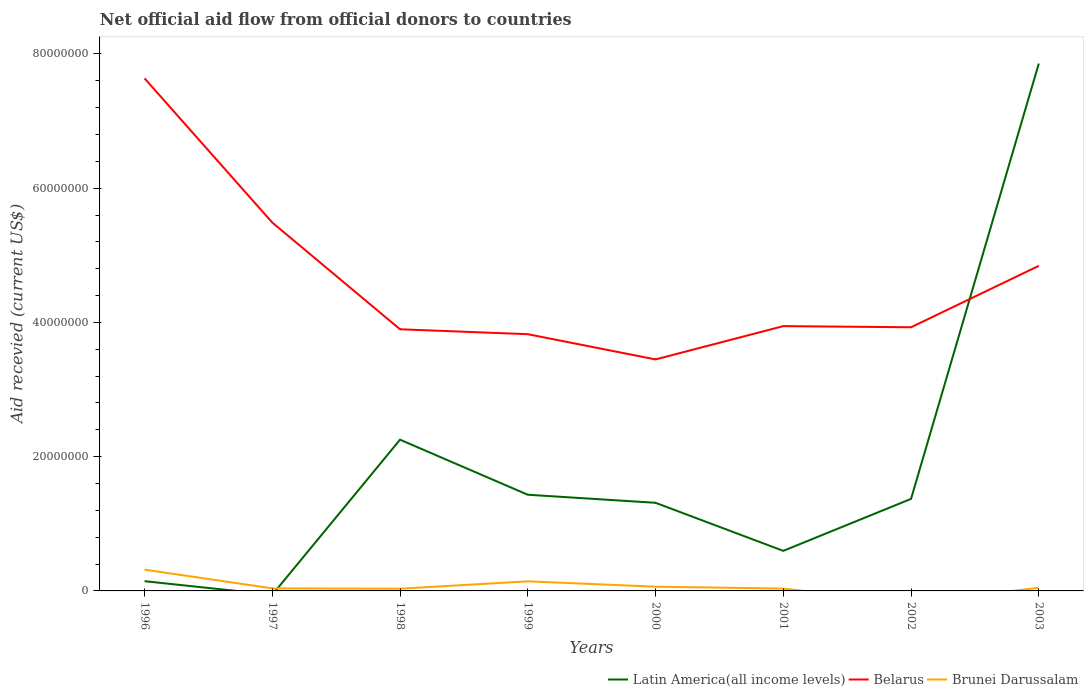Does the line corresponding to Latin America(all income levels) intersect with the line corresponding to Belarus?
Your response must be concise. Yes. Is the number of lines equal to the number of legend labels?
Offer a very short reply. No. Across all years, what is the maximum total aid received in Belarus?
Ensure brevity in your answer.  3.45e+07. What is the difference between the highest and the second highest total aid received in Belarus?
Ensure brevity in your answer.  4.19e+07. Is the total aid received in Latin America(all income levels) strictly greater than the total aid received in Belarus over the years?
Provide a short and direct response. No. What is the difference between two consecutive major ticks on the Y-axis?
Offer a terse response. 2.00e+07. Does the graph contain grids?
Keep it short and to the point. No. Where does the legend appear in the graph?
Keep it short and to the point. Bottom right. How many legend labels are there?
Ensure brevity in your answer.  3. What is the title of the graph?
Your answer should be compact. Net official aid flow from official donors to countries. Does "Europe(all income levels)" appear as one of the legend labels in the graph?
Offer a very short reply. No. What is the label or title of the X-axis?
Your answer should be very brief. Years. What is the label or title of the Y-axis?
Make the answer very short. Aid recevied (current US$). What is the Aid recevied (current US$) in Latin America(all income levels) in 1996?
Make the answer very short. 1.45e+06. What is the Aid recevied (current US$) of Belarus in 1996?
Give a very brief answer. 7.64e+07. What is the Aid recevied (current US$) of Brunei Darussalam in 1996?
Give a very brief answer. 3.17e+06. What is the Aid recevied (current US$) of Latin America(all income levels) in 1997?
Provide a succinct answer. 0. What is the Aid recevied (current US$) of Belarus in 1997?
Give a very brief answer. 5.49e+07. What is the Aid recevied (current US$) in Latin America(all income levels) in 1998?
Ensure brevity in your answer.  2.25e+07. What is the Aid recevied (current US$) in Belarus in 1998?
Ensure brevity in your answer.  3.90e+07. What is the Aid recevied (current US$) of Brunei Darussalam in 1998?
Your answer should be very brief. 3.30e+05. What is the Aid recevied (current US$) of Latin America(all income levels) in 1999?
Your response must be concise. 1.43e+07. What is the Aid recevied (current US$) of Belarus in 1999?
Make the answer very short. 3.82e+07. What is the Aid recevied (current US$) of Brunei Darussalam in 1999?
Your response must be concise. 1.43e+06. What is the Aid recevied (current US$) of Latin America(all income levels) in 2000?
Ensure brevity in your answer.  1.31e+07. What is the Aid recevied (current US$) of Belarus in 2000?
Your answer should be very brief. 3.45e+07. What is the Aid recevied (current US$) in Brunei Darussalam in 2000?
Make the answer very short. 6.30e+05. What is the Aid recevied (current US$) of Latin America(all income levels) in 2001?
Your response must be concise. 5.97e+06. What is the Aid recevied (current US$) of Belarus in 2001?
Your response must be concise. 3.94e+07. What is the Aid recevied (current US$) in Latin America(all income levels) in 2002?
Provide a succinct answer. 1.37e+07. What is the Aid recevied (current US$) in Belarus in 2002?
Make the answer very short. 3.93e+07. What is the Aid recevied (current US$) in Brunei Darussalam in 2002?
Your answer should be very brief. 0. What is the Aid recevied (current US$) of Latin America(all income levels) in 2003?
Make the answer very short. 7.86e+07. What is the Aid recevied (current US$) of Belarus in 2003?
Keep it short and to the point. 4.84e+07. What is the Aid recevied (current US$) of Brunei Darussalam in 2003?
Provide a short and direct response. 4.70e+05. Across all years, what is the maximum Aid recevied (current US$) in Latin America(all income levels)?
Ensure brevity in your answer.  7.86e+07. Across all years, what is the maximum Aid recevied (current US$) in Belarus?
Ensure brevity in your answer.  7.64e+07. Across all years, what is the maximum Aid recevied (current US$) in Brunei Darussalam?
Your answer should be compact. 3.17e+06. Across all years, what is the minimum Aid recevied (current US$) of Latin America(all income levels)?
Ensure brevity in your answer.  0. Across all years, what is the minimum Aid recevied (current US$) in Belarus?
Offer a very short reply. 3.45e+07. What is the total Aid recevied (current US$) in Latin America(all income levels) in the graph?
Ensure brevity in your answer.  1.50e+08. What is the total Aid recevied (current US$) in Belarus in the graph?
Give a very brief answer. 3.70e+08. What is the total Aid recevied (current US$) in Brunei Darussalam in the graph?
Your answer should be compact. 6.76e+06. What is the difference between the Aid recevied (current US$) in Belarus in 1996 and that in 1997?
Give a very brief answer. 2.15e+07. What is the difference between the Aid recevied (current US$) in Brunei Darussalam in 1996 and that in 1997?
Your answer should be compact. 2.79e+06. What is the difference between the Aid recevied (current US$) of Latin America(all income levels) in 1996 and that in 1998?
Keep it short and to the point. -2.11e+07. What is the difference between the Aid recevied (current US$) in Belarus in 1996 and that in 1998?
Make the answer very short. 3.74e+07. What is the difference between the Aid recevied (current US$) of Brunei Darussalam in 1996 and that in 1998?
Give a very brief answer. 2.84e+06. What is the difference between the Aid recevied (current US$) in Latin America(all income levels) in 1996 and that in 1999?
Give a very brief answer. -1.29e+07. What is the difference between the Aid recevied (current US$) in Belarus in 1996 and that in 1999?
Provide a succinct answer. 3.81e+07. What is the difference between the Aid recevied (current US$) of Brunei Darussalam in 1996 and that in 1999?
Your answer should be very brief. 1.74e+06. What is the difference between the Aid recevied (current US$) in Latin America(all income levels) in 1996 and that in 2000?
Your answer should be compact. -1.17e+07. What is the difference between the Aid recevied (current US$) of Belarus in 1996 and that in 2000?
Offer a terse response. 4.19e+07. What is the difference between the Aid recevied (current US$) in Brunei Darussalam in 1996 and that in 2000?
Ensure brevity in your answer.  2.54e+06. What is the difference between the Aid recevied (current US$) in Latin America(all income levels) in 1996 and that in 2001?
Give a very brief answer. -4.52e+06. What is the difference between the Aid recevied (current US$) in Belarus in 1996 and that in 2001?
Your answer should be compact. 3.69e+07. What is the difference between the Aid recevied (current US$) of Brunei Darussalam in 1996 and that in 2001?
Ensure brevity in your answer.  2.82e+06. What is the difference between the Aid recevied (current US$) in Latin America(all income levels) in 1996 and that in 2002?
Your response must be concise. -1.23e+07. What is the difference between the Aid recevied (current US$) of Belarus in 1996 and that in 2002?
Provide a succinct answer. 3.71e+07. What is the difference between the Aid recevied (current US$) of Latin America(all income levels) in 1996 and that in 2003?
Your response must be concise. -7.71e+07. What is the difference between the Aid recevied (current US$) of Belarus in 1996 and that in 2003?
Provide a short and direct response. 2.79e+07. What is the difference between the Aid recevied (current US$) of Brunei Darussalam in 1996 and that in 2003?
Ensure brevity in your answer.  2.70e+06. What is the difference between the Aid recevied (current US$) in Belarus in 1997 and that in 1998?
Your answer should be very brief. 1.59e+07. What is the difference between the Aid recevied (current US$) of Belarus in 1997 and that in 1999?
Provide a short and direct response. 1.66e+07. What is the difference between the Aid recevied (current US$) in Brunei Darussalam in 1997 and that in 1999?
Ensure brevity in your answer.  -1.05e+06. What is the difference between the Aid recevied (current US$) in Belarus in 1997 and that in 2000?
Keep it short and to the point. 2.04e+07. What is the difference between the Aid recevied (current US$) of Brunei Darussalam in 1997 and that in 2000?
Your answer should be very brief. -2.50e+05. What is the difference between the Aid recevied (current US$) in Belarus in 1997 and that in 2001?
Your answer should be very brief. 1.54e+07. What is the difference between the Aid recevied (current US$) of Brunei Darussalam in 1997 and that in 2001?
Give a very brief answer. 3.00e+04. What is the difference between the Aid recevied (current US$) in Belarus in 1997 and that in 2002?
Ensure brevity in your answer.  1.56e+07. What is the difference between the Aid recevied (current US$) of Belarus in 1997 and that in 2003?
Keep it short and to the point. 6.45e+06. What is the difference between the Aid recevied (current US$) of Brunei Darussalam in 1997 and that in 2003?
Make the answer very short. -9.00e+04. What is the difference between the Aid recevied (current US$) in Latin America(all income levels) in 1998 and that in 1999?
Your answer should be very brief. 8.20e+06. What is the difference between the Aid recevied (current US$) in Belarus in 1998 and that in 1999?
Provide a short and direct response. 7.30e+05. What is the difference between the Aid recevied (current US$) of Brunei Darussalam in 1998 and that in 1999?
Provide a short and direct response. -1.10e+06. What is the difference between the Aid recevied (current US$) in Latin America(all income levels) in 1998 and that in 2000?
Provide a succinct answer. 9.40e+06. What is the difference between the Aid recevied (current US$) of Belarus in 1998 and that in 2000?
Your answer should be compact. 4.49e+06. What is the difference between the Aid recevied (current US$) of Brunei Darussalam in 1998 and that in 2000?
Your response must be concise. -3.00e+05. What is the difference between the Aid recevied (current US$) in Latin America(all income levels) in 1998 and that in 2001?
Ensure brevity in your answer.  1.66e+07. What is the difference between the Aid recevied (current US$) of Belarus in 1998 and that in 2001?
Your response must be concise. -4.70e+05. What is the difference between the Aid recevied (current US$) of Latin America(all income levels) in 1998 and that in 2002?
Offer a very short reply. 8.82e+06. What is the difference between the Aid recevied (current US$) in Latin America(all income levels) in 1998 and that in 2003?
Ensure brevity in your answer.  -5.60e+07. What is the difference between the Aid recevied (current US$) of Belarus in 1998 and that in 2003?
Offer a very short reply. -9.45e+06. What is the difference between the Aid recevied (current US$) of Brunei Darussalam in 1998 and that in 2003?
Keep it short and to the point. -1.40e+05. What is the difference between the Aid recevied (current US$) of Latin America(all income levels) in 1999 and that in 2000?
Your response must be concise. 1.20e+06. What is the difference between the Aid recevied (current US$) of Belarus in 1999 and that in 2000?
Your answer should be very brief. 3.76e+06. What is the difference between the Aid recevied (current US$) in Latin America(all income levels) in 1999 and that in 2001?
Offer a terse response. 8.36e+06. What is the difference between the Aid recevied (current US$) of Belarus in 1999 and that in 2001?
Offer a terse response. -1.20e+06. What is the difference between the Aid recevied (current US$) of Brunei Darussalam in 1999 and that in 2001?
Your answer should be compact. 1.08e+06. What is the difference between the Aid recevied (current US$) in Latin America(all income levels) in 1999 and that in 2002?
Provide a short and direct response. 6.20e+05. What is the difference between the Aid recevied (current US$) of Belarus in 1999 and that in 2002?
Ensure brevity in your answer.  -1.03e+06. What is the difference between the Aid recevied (current US$) in Latin America(all income levels) in 1999 and that in 2003?
Keep it short and to the point. -6.42e+07. What is the difference between the Aid recevied (current US$) in Belarus in 1999 and that in 2003?
Offer a very short reply. -1.02e+07. What is the difference between the Aid recevied (current US$) of Brunei Darussalam in 1999 and that in 2003?
Your response must be concise. 9.60e+05. What is the difference between the Aid recevied (current US$) of Latin America(all income levels) in 2000 and that in 2001?
Give a very brief answer. 7.16e+06. What is the difference between the Aid recevied (current US$) of Belarus in 2000 and that in 2001?
Your response must be concise. -4.96e+06. What is the difference between the Aid recevied (current US$) in Brunei Darussalam in 2000 and that in 2001?
Your answer should be compact. 2.80e+05. What is the difference between the Aid recevied (current US$) in Latin America(all income levels) in 2000 and that in 2002?
Keep it short and to the point. -5.80e+05. What is the difference between the Aid recevied (current US$) of Belarus in 2000 and that in 2002?
Provide a succinct answer. -4.79e+06. What is the difference between the Aid recevied (current US$) in Latin America(all income levels) in 2000 and that in 2003?
Keep it short and to the point. -6.54e+07. What is the difference between the Aid recevied (current US$) in Belarus in 2000 and that in 2003?
Ensure brevity in your answer.  -1.39e+07. What is the difference between the Aid recevied (current US$) in Latin America(all income levels) in 2001 and that in 2002?
Provide a short and direct response. -7.74e+06. What is the difference between the Aid recevied (current US$) in Belarus in 2001 and that in 2002?
Provide a short and direct response. 1.70e+05. What is the difference between the Aid recevied (current US$) of Latin America(all income levels) in 2001 and that in 2003?
Provide a succinct answer. -7.26e+07. What is the difference between the Aid recevied (current US$) of Belarus in 2001 and that in 2003?
Ensure brevity in your answer.  -8.98e+06. What is the difference between the Aid recevied (current US$) in Brunei Darussalam in 2001 and that in 2003?
Give a very brief answer. -1.20e+05. What is the difference between the Aid recevied (current US$) of Latin America(all income levels) in 2002 and that in 2003?
Ensure brevity in your answer.  -6.49e+07. What is the difference between the Aid recevied (current US$) in Belarus in 2002 and that in 2003?
Offer a terse response. -9.15e+06. What is the difference between the Aid recevied (current US$) in Latin America(all income levels) in 1996 and the Aid recevied (current US$) in Belarus in 1997?
Your response must be concise. -5.34e+07. What is the difference between the Aid recevied (current US$) of Latin America(all income levels) in 1996 and the Aid recevied (current US$) of Brunei Darussalam in 1997?
Keep it short and to the point. 1.07e+06. What is the difference between the Aid recevied (current US$) of Belarus in 1996 and the Aid recevied (current US$) of Brunei Darussalam in 1997?
Ensure brevity in your answer.  7.60e+07. What is the difference between the Aid recevied (current US$) in Latin America(all income levels) in 1996 and the Aid recevied (current US$) in Belarus in 1998?
Give a very brief answer. -3.75e+07. What is the difference between the Aid recevied (current US$) of Latin America(all income levels) in 1996 and the Aid recevied (current US$) of Brunei Darussalam in 1998?
Ensure brevity in your answer.  1.12e+06. What is the difference between the Aid recevied (current US$) in Belarus in 1996 and the Aid recevied (current US$) in Brunei Darussalam in 1998?
Make the answer very short. 7.60e+07. What is the difference between the Aid recevied (current US$) in Latin America(all income levels) in 1996 and the Aid recevied (current US$) in Belarus in 1999?
Make the answer very short. -3.68e+07. What is the difference between the Aid recevied (current US$) in Belarus in 1996 and the Aid recevied (current US$) in Brunei Darussalam in 1999?
Ensure brevity in your answer.  7.49e+07. What is the difference between the Aid recevied (current US$) of Latin America(all income levels) in 1996 and the Aid recevied (current US$) of Belarus in 2000?
Provide a succinct answer. -3.30e+07. What is the difference between the Aid recevied (current US$) in Latin America(all income levels) in 1996 and the Aid recevied (current US$) in Brunei Darussalam in 2000?
Your response must be concise. 8.20e+05. What is the difference between the Aid recevied (current US$) in Belarus in 1996 and the Aid recevied (current US$) in Brunei Darussalam in 2000?
Offer a terse response. 7.57e+07. What is the difference between the Aid recevied (current US$) of Latin America(all income levels) in 1996 and the Aid recevied (current US$) of Belarus in 2001?
Offer a terse response. -3.80e+07. What is the difference between the Aid recevied (current US$) in Latin America(all income levels) in 1996 and the Aid recevied (current US$) in Brunei Darussalam in 2001?
Offer a terse response. 1.10e+06. What is the difference between the Aid recevied (current US$) of Belarus in 1996 and the Aid recevied (current US$) of Brunei Darussalam in 2001?
Your answer should be compact. 7.60e+07. What is the difference between the Aid recevied (current US$) of Latin America(all income levels) in 1996 and the Aid recevied (current US$) of Belarus in 2002?
Keep it short and to the point. -3.78e+07. What is the difference between the Aid recevied (current US$) of Latin America(all income levels) in 1996 and the Aid recevied (current US$) of Belarus in 2003?
Ensure brevity in your answer.  -4.70e+07. What is the difference between the Aid recevied (current US$) of Latin America(all income levels) in 1996 and the Aid recevied (current US$) of Brunei Darussalam in 2003?
Your response must be concise. 9.80e+05. What is the difference between the Aid recevied (current US$) in Belarus in 1996 and the Aid recevied (current US$) in Brunei Darussalam in 2003?
Provide a succinct answer. 7.59e+07. What is the difference between the Aid recevied (current US$) in Belarus in 1997 and the Aid recevied (current US$) in Brunei Darussalam in 1998?
Offer a terse response. 5.46e+07. What is the difference between the Aid recevied (current US$) in Belarus in 1997 and the Aid recevied (current US$) in Brunei Darussalam in 1999?
Offer a very short reply. 5.34e+07. What is the difference between the Aid recevied (current US$) of Belarus in 1997 and the Aid recevied (current US$) of Brunei Darussalam in 2000?
Your answer should be very brief. 5.42e+07. What is the difference between the Aid recevied (current US$) of Belarus in 1997 and the Aid recevied (current US$) of Brunei Darussalam in 2001?
Provide a succinct answer. 5.45e+07. What is the difference between the Aid recevied (current US$) in Belarus in 1997 and the Aid recevied (current US$) in Brunei Darussalam in 2003?
Your answer should be compact. 5.44e+07. What is the difference between the Aid recevied (current US$) of Latin America(all income levels) in 1998 and the Aid recevied (current US$) of Belarus in 1999?
Provide a short and direct response. -1.57e+07. What is the difference between the Aid recevied (current US$) of Latin America(all income levels) in 1998 and the Aid recevied (current US$) of Brunei Darussalam in 1999?
Keep it short and to the point. 2.11e+07. What is the difference between the Aid recevied (current US$) in Belarus in 1998 and the Aid recevied (current US$) in Brunei Darussalam in 1999?
Make the answer very short. 3.76e+07. What is the difference between the Aid recevied (current US$) in Latin America(all income levels) in 1998 and the Aid recevied (current US$) in Belarus in 2000?
Keep it short and to the point. -1.20e+07. What is the difference between the Aid recevied (current US$) of Latin America(all income levels) in 1998 and the Aid recevied (current US$) of Brunei Darussalam in 2000?
Make the answer very short. 2.19e+07. What is the difference between the Aid recevied (current US$) in Belarus in 1998 and the Aid recevied (current US$) in Brunei Darussalam in 2000?
Provide a succinct answer. 3.84e+07. What is the difference between the Aid recevied (current US$) of Latin America(all income levels) in 1998 and the Aid recevied (current US$) of Belarus in 2001?
Make the answer very short. -1.69e+07. What is the difference between the Aid recevied (current US$) of Latin America(all income levels) in 1998 and the Aid recevied (current US$) of Brunei Darussalam in 2001?
Make the answer very short. 2.22e+07. What is the difference between the Aid recevied (current US$) of Belarus in 1998 and the Aid recevied (current US$) of Brunei Darussalam in 2001?
Your answer should be very brief. 3.86e+07. What is the difference between the Aid recevied (current US$) of Latin America(all income levels) in 1998 and the Aid recevied (current US$) of Belarus in 2002?
Your answer should be compact. -1.68e+07. What is the difference between the Aid recevied (current US$) in Latin America(all income levels) in 1998 and the Aid recevied (current US$) in Belarus in 2003?
Make the answer very short. -2.59e+07. What is the difference between the Aid recevied (current US$) in Latin America(all income levels) in 1998 and the Aid recevied (current US$) in Brunei Darussalam in 2003?
Your answer should be compact. 2.21e+07. What is the difference between the Aid recevied (current US$) of Belarus in 1998 and the Aid recevied (current US$) of Brunei Darussalam in 2003?
Provide a succinct answer. 3.85e+07. What is the difference between the Aid recevied (current US$) in Latin America(all income levels) in 1999 and the Aid recevied (current US$) in Belarus in 2000?
Offer a very short reply. -2.02e+07. What is the difference between the Aid recevied (current US$) in Latin America(all income levels) in 1999 and the Aid recevied (current US$) in Brunei Darussalam in 2000?
Provide a succinct answer. 1.37e+07. What is the difference between the Aid recevied (current US$) of Belarus in 1999 and the Aid recevied (current US$) of Brunei Darussalam in 2000?
Make the answer very short. 3.76e+07. What is the difference between the Aid recevied (current US$) in Latin America(all income levels) in 1999 and the Aid recevied (current US$) in Belarus in 2001?
Your answer should be compact. -2.51e+07. What is the difference between the Aid recevied (current US$) in Latin America(all income levels) in 1999 and the Aid recevied (current US$) in Brunei Darussalam in 2001?
Make the answer very short. 1.40e+07. What is the difference between the Aid recevied (current US$) of Belarus in 1999 and the Aid recevied (current US$) of Brunei Darussalam in 2001?
Provide a succinct answer. 3.79e+07. What is the difference between the Aid recevied (current US$) in Latin America(all income levels) in 1999 and the Aid recevied (current US$) in Belarus in 2002?
Give a very brief answer. -2.50e+07. What is the difference between the Aid recevied (current US$) in Latin America(all income levels) in 1999 and the Aid recevied (current US$) in Belarus in 2003?
Provide a short and direct response. -3.41e+07. What is the difference between the Aid recevied (current US$) of Latin America(all income levels) in 1999 and the Aid recevied (current US$) of Brunei Darussalam in 2003?
Your response must be concise. 1.39e+07. What is the difference between the Aid recevied (current US$) in Belarus in 1999 and the Aid recevied (current US$) in Brunei Darussalam in 2003?
Ensure brevity in your answer.  3.78e+07. What is the difference between the Aid recevied (current US$) of Latin America(all income levels) in 2000 and the Aid recevied (current US$) of Belarus in 2001?
Your answer should be very brief. -2.63e+07. What is the difference between the Aid recevied (current US$) in Latin America(all income levels) in 2000 and the Aid recevied (current US$) in Brunei Darussalam in 2001?
Give a very brief answer. 1.28e+07. What is the difference between the Aid recevied (current US$) of Belarus in 2000 and the Aid recevied (current US$) of Brunei Darussalam in 2001?
Offer a very short reply. 3.41e+07. What is the difference between the Aid recevied (current US$) in Latin America(all income levels) in 2000 and the Aid recevied (current US$) in Belarus in 2002?
Give a very brief answer. -2.62e+07. What is the difference between the Aid recevied (current US$) of Latin America(all income levels) in 2000 and the Aid recevied (current US$) of Belarus in 2003?
Give a very brief answer. -3.53e+07. What is the difference between the Aid recevied (current US$) of Latin America(all income levels) in 2000 and the Aid recevied (current US$) of Brunei Darussalam in 2003?
Make the answer very short. 1.27e+07. What is the difference between the Aid recevied (current US$) in Belarus in 2000 and the Aid recevied (current US$) in Brunei Darussalam in 2003?
Give a very brief answer. 3.40e+07. What is the difference between the Aid recevied (current US$) of Latin America(all income levels) in 2001 and the Aid recevied (current US$) of Belarus in 2002?
Ensure brevity in your answer.  -3.33e+07. What is the difference between the Aid recevied (current US$) in Latin America(all income levels) in 2001 and the Aid recevied (current US$) in Belarus in 2003?
Provide a short and direct response. -4.25e+07. What is the difference between the Aid recevied (current US$) in Latin America(all income levels) in 2001 and the Aid recevied (current US$) in Brunei Darussalam in 2003?
Your response must be concise. 5.50e+06. What is the difference between the Aid recevied (current US$) of Belarus in 2001 and the Aid recevied (current US$) of Brunei Darussalam in 2003?
Your answer should be compact. 3.90e+07. What is the difference between the Aid recevied (current US$) of Latin America(all income levels) in 2002 and the Aid recevied (current US$) of Belarus in 2003?
Ensure brevity in your answer.  -3.47e+07. What is the difference between the Aid recevied (current US$) of Latin America(all income levels) in 2002 and the Aid recevied (current US$) of Brunei Darussalam in 2003?
Your response must be concise. 1.32e+07. What is the difference between the Aid recevied (current US$) in Belarus in 2002 and the Aid recevied (current US$) in Brunei Darussalam in 2003?
Offer a terse response. 3.88e+07. What is the average Aid recevied (current US$) of Latin America(all income levels) per year?
Your answer should be very brief. 1.87e+07. What is the average Aid recevied (current US$) in Belarus per year?
Your answer should be compact. 4.63e+07. What is the average Aid recevied (current US$) of Brunei Darussalam per year?
Give a very brief answer. 8.45e+05. In the year 1996, what is the difference between the Aid recevied (current US$) of Latin America(all income levels) and Aid recevied (current US$) of Belarus?
Keep it short and to the point. -7.49e+07. In the year 1996, what is the difference between the Aid recevied (current US$) of Latin America(all income levels) and Aid recevied (current US$) of Brunei Darussalam?
Your response must be concise. -1.72e+06. In the year 1996, what is the difference between the Aid recevied (current US$) in Belarus and Aid recevied (current US$) in Brunei Darussalam?
Offer a terse response. 7.32e+07. In the year 1997, what is the difference between the Aid recevied (current US$) of Belarus and Aid recevied (current US$) of Brunei Darussalam?
Your answer should be compact. 5.45e+07. In the year 1998, what is the difference between the Aid recevied (current US$) in Latin America(all income levels) and Aid recevied (current US$) in Belarus?
Provide a short and direct response. -1.64e+07. In the year 1998, what is the difference between the Aid recevied (current US$) of Latin America(all income levels) and Aid recevied (current US$) of Brunei Darussalam?
Offer a very short reply. 2.22e+07. In the year 1998, what is the difference between the Aid recevied (current US$) in Belarus and Aid recevied (current US$) in Brunei Darussalam?
Your response must be concise. 3.86e+07. In the year 1999, what is the difference between the Aid recevied (current US$) of Latin America(all income levels) and Aid recevied (current US$) of Belarus?
Give a very brief answer. -2.39e+07. In the year 1999, what is the difference between the Aid recevied (current US$) in Latin America(all income levels) and Aid recevied (current US$) in Brunei Darussalam?
Your answer should be compact. 1.29e+07. In the year 1999, what is the difference between the Aid recevied (current US$) in Belarus and Aid recevied (current US$) in Brunei Darussalam?
Your answer should be very brief. 3.68e+07. In the year 2000, what is the difference between the Aid recevied (current US$) of Latin America(all income levels) and Aid recevied (current US$) of Belarus?
Provide a short and direct response. -2.14e+07. In the year 2000, what is the difference between the Aid recevied (current US$) in Latin America(all income levels) and Aid recevied (current US$) in Brunei Darussalam?
Provide a succinct answer. 1.25e+07. In the year 2000, what is the difference between the Aid recevied (current US$) in Belarus and Aid recevied (current US$) in Brunei Darussalam?
Keep it short and to the point. 3.39e+07. In the year 2001, what is the difference between the Aid recevied (current US$) of Latin America(all income levels) and Aid recevied (current US$) of Belarus?
Offer a terse response. -3.35e+07. In the year 2001, what is the difference between the Aid recevied (current US$) of Latin America(all income levels) and Aid recevied (current US$) of Brunei Darussalam?
Offer a very short reply. 5.62e+06. In the year 2001, what is the difference between the Aid recevied (current US$) of Belarus and Aid recevied (current US$) of Brunei Darussalam?
Provide a succinct answer. 3.91e+07. In the year 2002, what is the difference between the Aid recevied (current US$) in Latin America(all income levels) and Aid recevied (current US$) in Belarus?
Make the answer very short. -2.56e+07. In the year 2003, what is the difference between the Aid recevied (current US$) in Latin America(all income levels) and Aid recevied (current US$) in Belarus?
Your response must be concise. 3.01e+07. In the year 2003, what is the difference between the Aid recevied (current US$) in Latin America(all income levels) and Aid recevied (current US$) in Brunei Darussalam?
Make the answer very short. 7.81e+07. In the year 2003, what is the difference between the Aid recevied (current US$) of Belarus and Aid recevied (current US$) of Brunei Darussalam?
Provide a succinct answer. 4.80e+07. What is the ratio of the Aid recevied (current US$) in Belarus in 1996 to that in 1997?
Your answer should be very brief. 1.39. What is the ratio of the Aid recevied (current US$) of Brunei Darussalam in 1996 to that in 1997?
Your answer should be very brief. 8.34. What is the ratio of the Aid recevied (current US$) in Latin America(all income levels) in 1996 to that in 1998?
Give a very brief answer. 0.06. What is the ratio of the Aid recevied (current US$) of Belarus in 1996 to that in 1998?
Make the answer very short. 1.96. What is the ratio of the Aid recevied (current US$) in Brunei Darussalam in 1996 to that in 1998?
Offer a terse response. 9.61. What is the ratio of the Aid recevied (current US$) in Latin America(all income levels) in 1996 to that in 1999?
Keep it short and to the point. 0.1. What is the ratio of the Aid recevied (current US$) of Belarus in 1996 to that in 1999?
Provide a succinct answer. 2. What is the ratio of the Aid recevied (current US$) in Brunei Darussalam in 1996 to that in 1999?
Offer a very short reply. 2.22. What is the ratio of the Aid recevied (current US$) in Latin America(all income levels) in 1996 to that in 2000?
Offer a very short reply. 0.11. What is the ratio of the Aid recevied (current US$) of Belarus in 1996 to that in 2000?
Your answer should be very brief. 2.21. What is the ratio of the Aid recevied (current US$) of Brunei Darussalam in 1996 to that in 2000?
Ensure brevity in your answer.  5.03. What is the ratio of the Aid recevied (current US$) in Latin America(all income levels) in 1996 to that in 2001?
Ensure brevity in your answer.  0.24. What is the ratio of the Aid recevied (current US$) in Belarus in 1996 to that in 2001?
Make the answer very short. 1.94. What is the ratio of the Aid recevied (current US$) in Brunei Darussalam in 1996 to that in 2001?
Offer a terse response. 9.06. What is the ratio of the Aid recevied (current US$) in Latin America(all income levels) in 1996 to that in 2002?
Your response must be concise. 0.11. What is the ratio of the Aid recevied (current US$) in Belarus in 1996 to that in 2002?
Your answer should be compact. 1.94. What is the ratio of the Aid recevied (current US$) of Latin America(all income levels) in 1996 to that in 2003?
Provide a succinct answer. 0.02. What is the ratio of the Aid recevied (current US$) of Belarus in 1996 to that in 2003?
Ensure brevity in your answer.  1.58. What is the ratio of the Aid recevied (current US$) of Brunei Darussalam in 1996 to that in 2003?
Keep it short and to the point. 6.74. What is the ratio of the Aid recevied (current US$) in Belarus in 1997 to that in 1998?
Keep it short and to the point. 1.41. What is the ratio of the Aid recevied (current US$) in Brunei Darussalam in 1997 to that in 1998?
Provide a short and direct response. 1.15. What is the ratio of the Aid recevied (current US$) of Belarus in 1997 to that in 1999?
Keep it short and to the point. 1.43. What is the ratio of the Aid recevied (current US$) of Brunei Darussalam in 1997 to that in 1999?
Your answer should be compact. 0.27. What is the ratio of the Aid recevied (current US$) in Belarus in 1997 to that in 2000?
Your response must be concise. 1.59. What is the ratio of the Aid recevied (current US$) in Brunei Darussalam in 1997 to that in 2000?
Make the answer very short. 0.6. What is the ratio of the Aid recevied (current US$) of Belarus in 1997 to that in 2001?
Give a very brief answer. 1.39. What is the ratio of the Aid recevied (current US$) in Brunei Darussalam in 1997 to that in 2001?
Offer a terse response. 1.09. What is the ratio of the Aid recevied (current US$) in Belarus in 1997 to that in 2002?
Give a very brief answer. 1.4. What is the ratio of the Aid recevied (current US$) in Belarus in 1997 to that in 2003?
Your answer should be very brief. 1.13. What is the ratio of the Aid recevied (current US$) in Brunei Darussalam in 1997 to that in 2003?
Give a very brief answer. 0.81. What is the ratio of the Aid recevied (current US$) of Latin America(all income levels) in 1998 to that in 1999?
Offer a very short reply. 1.57. What is the ratio of the Aid recevied (current US$) in Belarus in 1998 to that in 1999?
Make the answer very short. 1.02. What is the ratio of the Aid recevied (current US$) in Brunei Darussalam in 1998 to that in 1999?
Your answer should be very brief. 0.23. What is the ratio of the Aid recevied (current US$) of Latin America(all income levels) in 1998 to that in 2000?
Offer a very short reply. 1.72. What is the ratio of the Aid recevied (current US$) in Belarus in 1998 to that in 2000?
Ensure brevity in your answer.  1.13. What is the ratio of the Aid recevied (current US$) in Brunei Darussalam in 1998 to that in 2000?
Offer a terse response. 0.52. What is the ratio of the Aid recevied (current US$) in Latin America(all income levels) in 1998 to that in 2001?
Provide a succinct answer. 3.77. What is the ratio of the Aid recevied (current US$) of Belarus in 1998 to that in 2001?
Offer a very short reply. 0.99. What is the ratio of the Aid recevied (current US$) in Brunei Darussalam in 1998 to that in 2001?
Offer a very short reply. 0.94. What is the ratio of the Aid recevied (current US$) of Latin America(all income levels) in 1998 to that in 2002?
Ensure brevity in your answer.  1.64. What is the ratio of the Aid recevied (current US$) of Belarus in 1998 to that in 2002?
Provide a succinct answer. 0.99. What is the ratio of the Aid recevied (current US$) in Latin America(all income levels) in 1998 to that in 2003?
Keep it short and to the point. 0.29. What is the ratio of the Aid recevied (current US$) of Belarus in 1998 to that in 2003?
Provide a succinct answer. 0.8. What is the ratio of the Aid recevied (current US$) of Brunei Darussalam in 1998 to that in 2003?
Ensure brevity in your answer.  0.7. What is the ratio of the Aid recevied (current US$) of Latin America(all income levels) in 1999 to that in 2000?
Offer a very short reply. 1.09. What is the ratio of the Aid recevied (current US$) of Belarus in 1999 to that in 2000?
Offer a terse response. 1.11. What is the ratio of the Aid recevied (current US$) in Brunei Darussalam in 1999 to that in 2000?
Your answer should be compact. 2.27. What is the ratio of the Aid recevied (current US$) of Latin America(all income levels) in 1999 to that in 2001?
Ensure brevity in your answer.  2.4. What is the ratio of the Aid recevied (current US$) of Belarus in 1999 to that in 2001?
Provide a succinct answer. 0.97. What is the ratio of the Aid recevied (current US$) of Brunei Darussalam in 1999 to that in 2001?
Offer a very short reply. 4.09. What is the ratio of the Aid recevied (current US$) in Latin America(all income levels) in 1999 to that in 2002?
Provide a short and direct response. 1.05. What is the ratio of the Aid recevied (current US$) of Belarus in 1999 to that in 2002?
Keep it short and to the point. 0.97. What is the ratio of the Aid recevied (current US$) in Latin America(all income levels) in 1999 to that in 2003?
Provide a short and direct response. 0.18. What is the ratio of the Aid recevied (current US$) of Belarus in 1999 to that in 2003?
Give a very brief answer. 0.79. What is the ratio of the Aid recevied (current US$) of Brunei Darussalam in 1999 to that in 2003?
Make the answer very short. 3.04. What is the ratio of the Aid recevied (current US$) in Latin America(all income levels) in 2000 to that in 2001?
Keep it short and to the point. 2.2. What is the ratio of the Aid recevied (current US$) in Belarus in 2000 to that in 2001?
Provide a short and direct response. 0.87. What is the ratio of the Aid recevied (current US$) in Brunei Darussalam in 2000 to that in 2001?
Offer a terse response. 1.8. What is the ratio of the Aid recevied (current US$) in Latin America(all income levels) in 2000 to that in 2002?
Offer a terse response. 0.96. What is the ratio of the Aid recevied (current US$) of Belarus in 2000 to that in 2002?
Make the answer very short. 0.88. What is the ratio of the Aid recevied (current US$) in Latin America(all income levels) in 2000 to that in 2003?
Provide a succinct answer. 0.17. What is the ratio of the Aid recevied (current US$) of Belarus in 2000 to that in 2003?
Give a very brief answer. 0.71. What is the ratio of the Aid recevied (current US$) in Brunei Darussalam in 2000 to that in 2003?
Your answer should be very brief. 1.34. What is the ratio of the Aid recevied (current US$) of Latin America(all income levels) in 2001 to that in 2002?
Provide a succinct answer. 0.44. What is the ratio of the Aid recevied (current US$) of Latin America(all income levels) in 2001 to that in 2003?
Offer a terse response. 0.08. What is the ratio of the Aid recevied (current US$) of Belarus in 2001 to that in 2003?
Offer a terse response. 0.81. What is the ratio of the Aid recevied (current US$) of Brunei Darussalam in 2001 to that in 2003?
Ensure brevity in your answer.  0.74. What is the ratio of the Aid recevied (current US$) of Latin America(all income levels) in 2002 to that in 2003?
Offer a very short reply. 0.17. What is the ratio of the Aid recevied (current US$) in Belarus in 2002 to that in 2003?
Keep it short and to the point. 0.81. What is the difference between the highest and the second highest Aid recevied (current US$) in Latin America(all income levels)?
Give a very brief answer. 5.60e+07. What is the difference between the highest and the second highest Aid recevied (current US$) of Belarus?
Give a very brief answer. 2.15e+07. What is the difference between the highest and the second highest Aid recevied (current US$) in Brunei Darussalam?
Offer a terse response. 1.74e+06. What is the difference between the highest and the lowest Aid recevied (current US$) of Latin America(all income levels)?
Your response must be concise. 7.86e+07. What is the difference between the highest and the lowest Aid recevied (current US$) in Belarus?
Ensure brevity in your answer.  4.19e+07. What is the difference between the highest and the lowest Aid recevied (current US$) of Brunei Darussalam?
Give a very brief answer. 3.17e+06. 